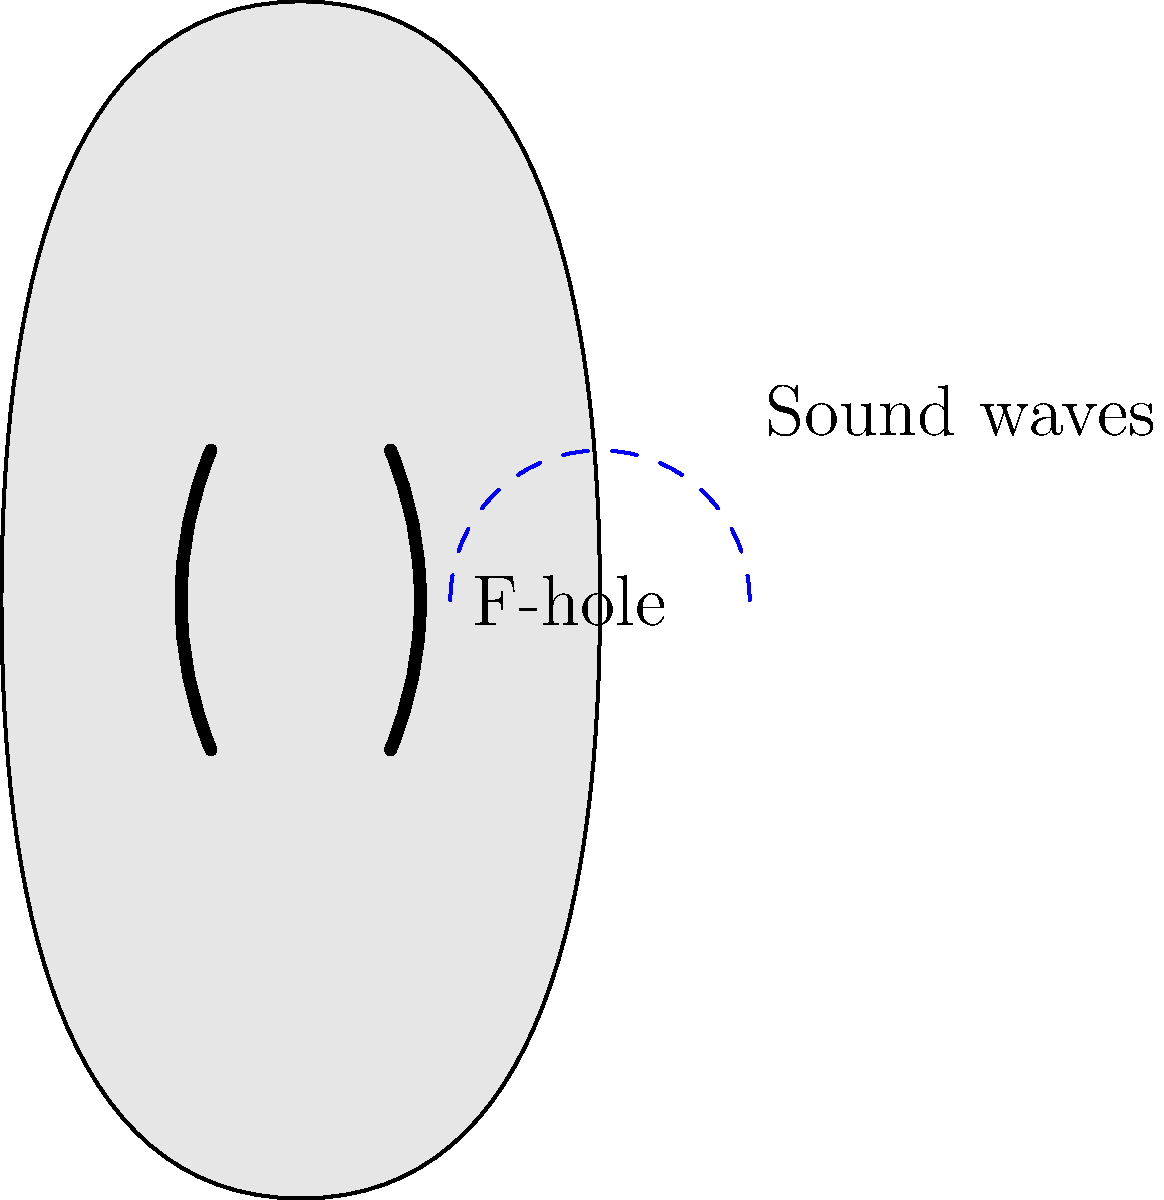Consider the f-holes on a violin as shown in the diagram. How does the shape of these f-holes contribute to the instrument's sound propagation and overall tonal quality? To understand the impact of f-holes on a violin's sound propagation, let's break it down step-by-step:

1. Function of f-holes: F-holes serve as openings that allow air to move in and out of the violin's body, coupling the vibrations of the instrument's top plate to the air inside and outside the body.

2. Shape significance: The elongated f-shape is crucial for efficient sound propagation:
   a) The curved edges create a smooth path for air movement.
   b) The narrow width helps to control the air flow.

3. Helmholtz resonance: The f-holes contribute to the Helmholtz resonance of the violin body, which is described by the equation:

   $$f = \frac{c}{2\pi} \sqrt{\frac{A}{VL}}$$

   Where $f$ is the resonant frequency, $c$ is the speed of sound, $A$ is the total area of the f-holes, $V$ is the volume of the body, and $L$ is the effective length of the f-holes.

4. Air spring effect: The air inside the violin body acts as a spring, with the f-holes allowing it to compress and expand, enhancing the lower frequencies of the instrument.

5. Radiation efficiency: The f-holes increase the radiation efficiency of the violin, especially at lower frequencies, by allowing more effective coupling between the vibrating air inside the body and the surrounding air.

6. Tonal quality: The specific shape and size of the f-holes influence the violin's tonal quality by affecting:
   a) The balance between low and high frequencies
   b) The overall volume and projection of the instrument
   c) The richness and complexity of overtones

7. Historical evolution: The f-hole shape evolved from earlier circular sound holes, with the current design optimized for better sound projection and tonal qualities.

In summary, the f-holes' shape is critical for efficient sound propagation, contributing to the violin's resonance, tonal quality, and overall acoustic performance.
Answer: The f-holes' elongated shape optimizes air flow, enhances Helmholtz resonance, improves radiation efficiency, and balances frequency response, resulting in better sound propagation and richer tonal quality. 